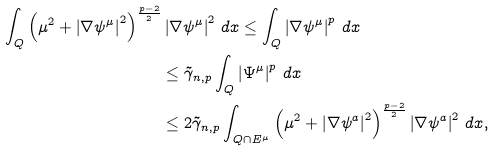<formula> <loc_0><loc_0><loc_500><loc_500>\int _ { Q } \left ( \mu ^ { 2 } + \left | \nabla \psi ^ { \mu } \right | ^ { 2 } \right ) ^ { \frac { p - 2 } { 2 } } & \left | \nabla \psi ^ { \mu } \right | ^ { 2 } \, d x \leq \int _ { Q } \left | \nabla \psi ^ { \mu } \right | ^ { p } \, d x \\ & \leq \tilde { \gamma } _ { n , p } \int _ { Q } \left | \Psi ^ { \mu } \right | ^ { p } \, d x \\ & \leq 2 \tilde { \gamma } _ { n , p } \int _ { Q \cap E ^ { _ { \mu } } } \left ( \mu ^ { 2 } + \left | \nabla \psi ^ { a } \right | ^ { 2 } \right ) ^ { \frac { p - 2 } { 2 } } \left | \nabla \psi ^ { a } \right | ^ { 2 } \, d x ,</formula> 